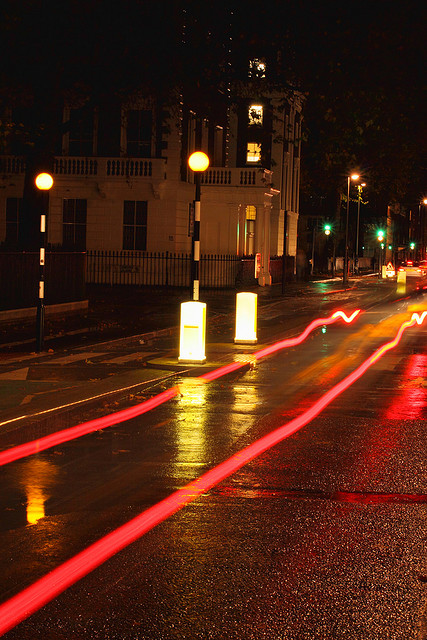<image>What sort of photography was used to capture the blurred red line? It is unknown what sort of photography was used to capture the blurred red line. It can be 'slow motion', 'stop motion' or 'time lapse'. What sort of photography was used to capture the blurred red line? I don't know what sort of photography was used to capture the blurred red line. It can be slow motion, stop motion, time lapse, fast forward, or quicktime. 